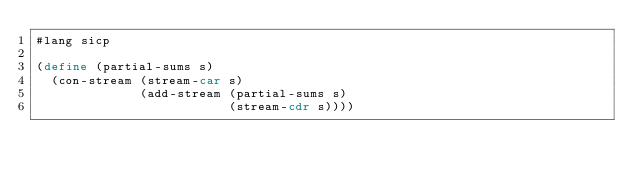<code> <loc_0><loc_0><loc_500><loc_500><_Scheme_>#lang sicp

(define (partial-sums s)
  (con-stream (stream-car s) 
              (add-stream (partial-sums s) 
                          (stream-cdr s))))
</code> 